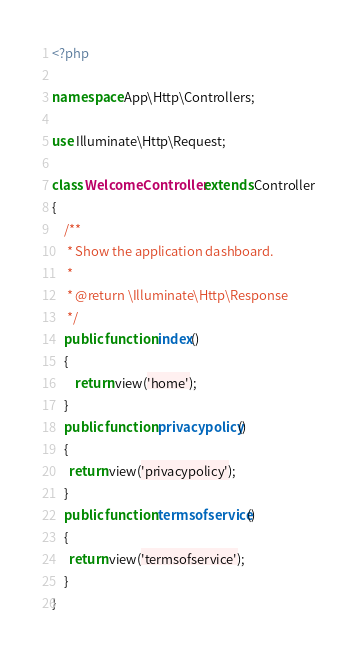Convert code to text. <code><loc_0><loc_0><loc_500><loc_500><_PHP_><?php

namespace App\Http\Controllers;

use Illuminate\Http\Request;

class WelcomeController extends Controller
{
    /**
     * Show the application dashboard.
     *
     * @return \Illuminate\Http\Response
     */
    public function index()
    {
        return view('home');
    }
    public function privacypolicy()
    {
      return view('privacypolicy');
    }
    public function termsofservice()
    {
      return view('termsofservice');
    }
}
</code> 